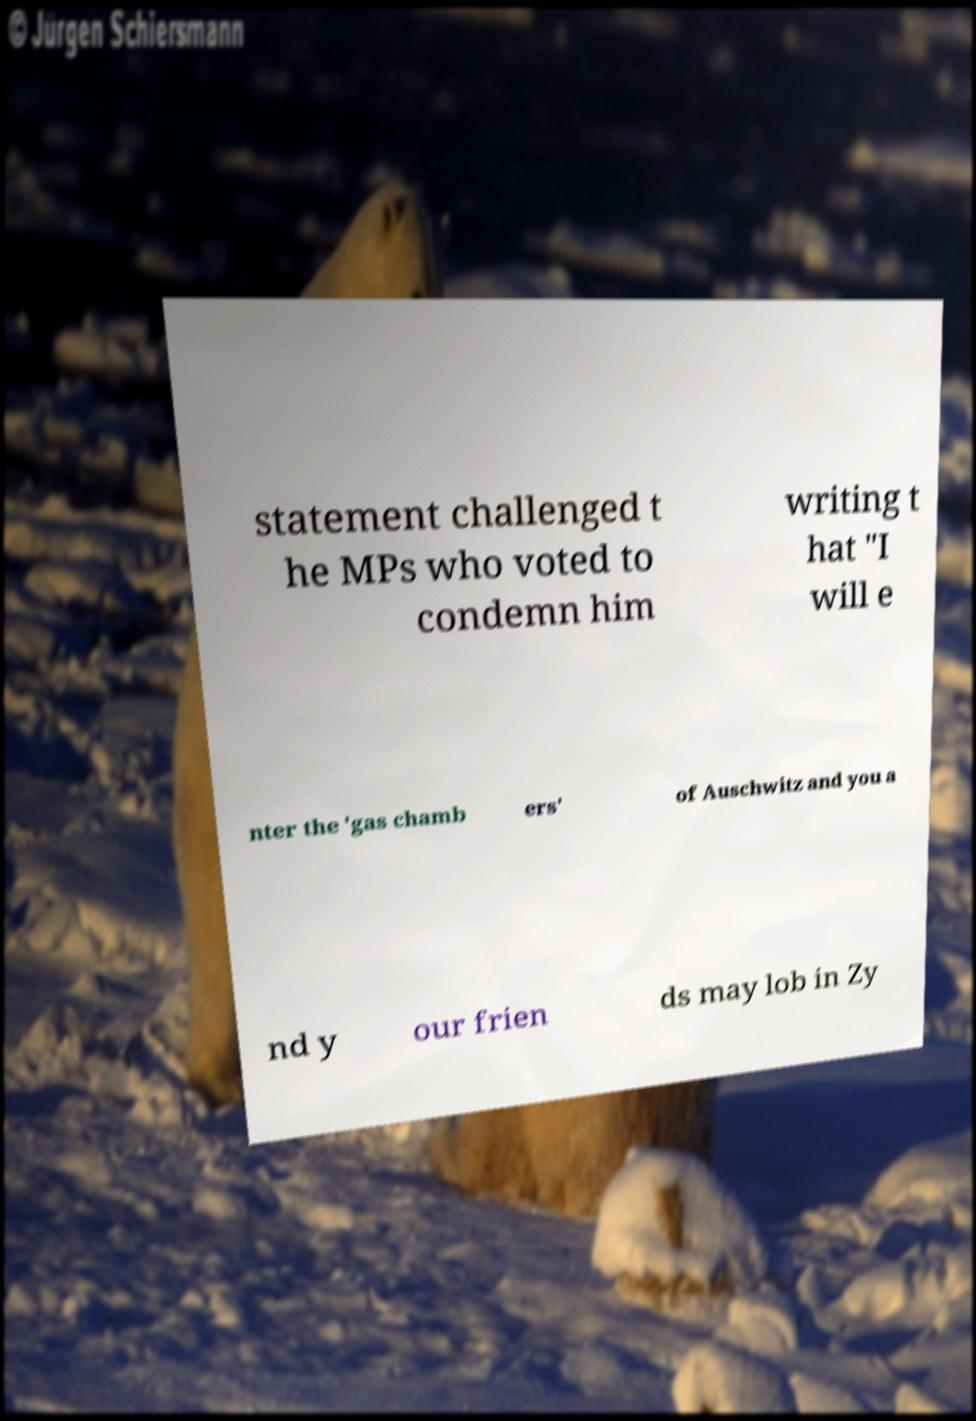Could you extract and type out the text from this image? statement challenged t he MPs who voted to condemn him writing t hat "I will e nter the 'gas chamb ers' of Auschwitz and you a nd y our frien ds may lob in Zy 